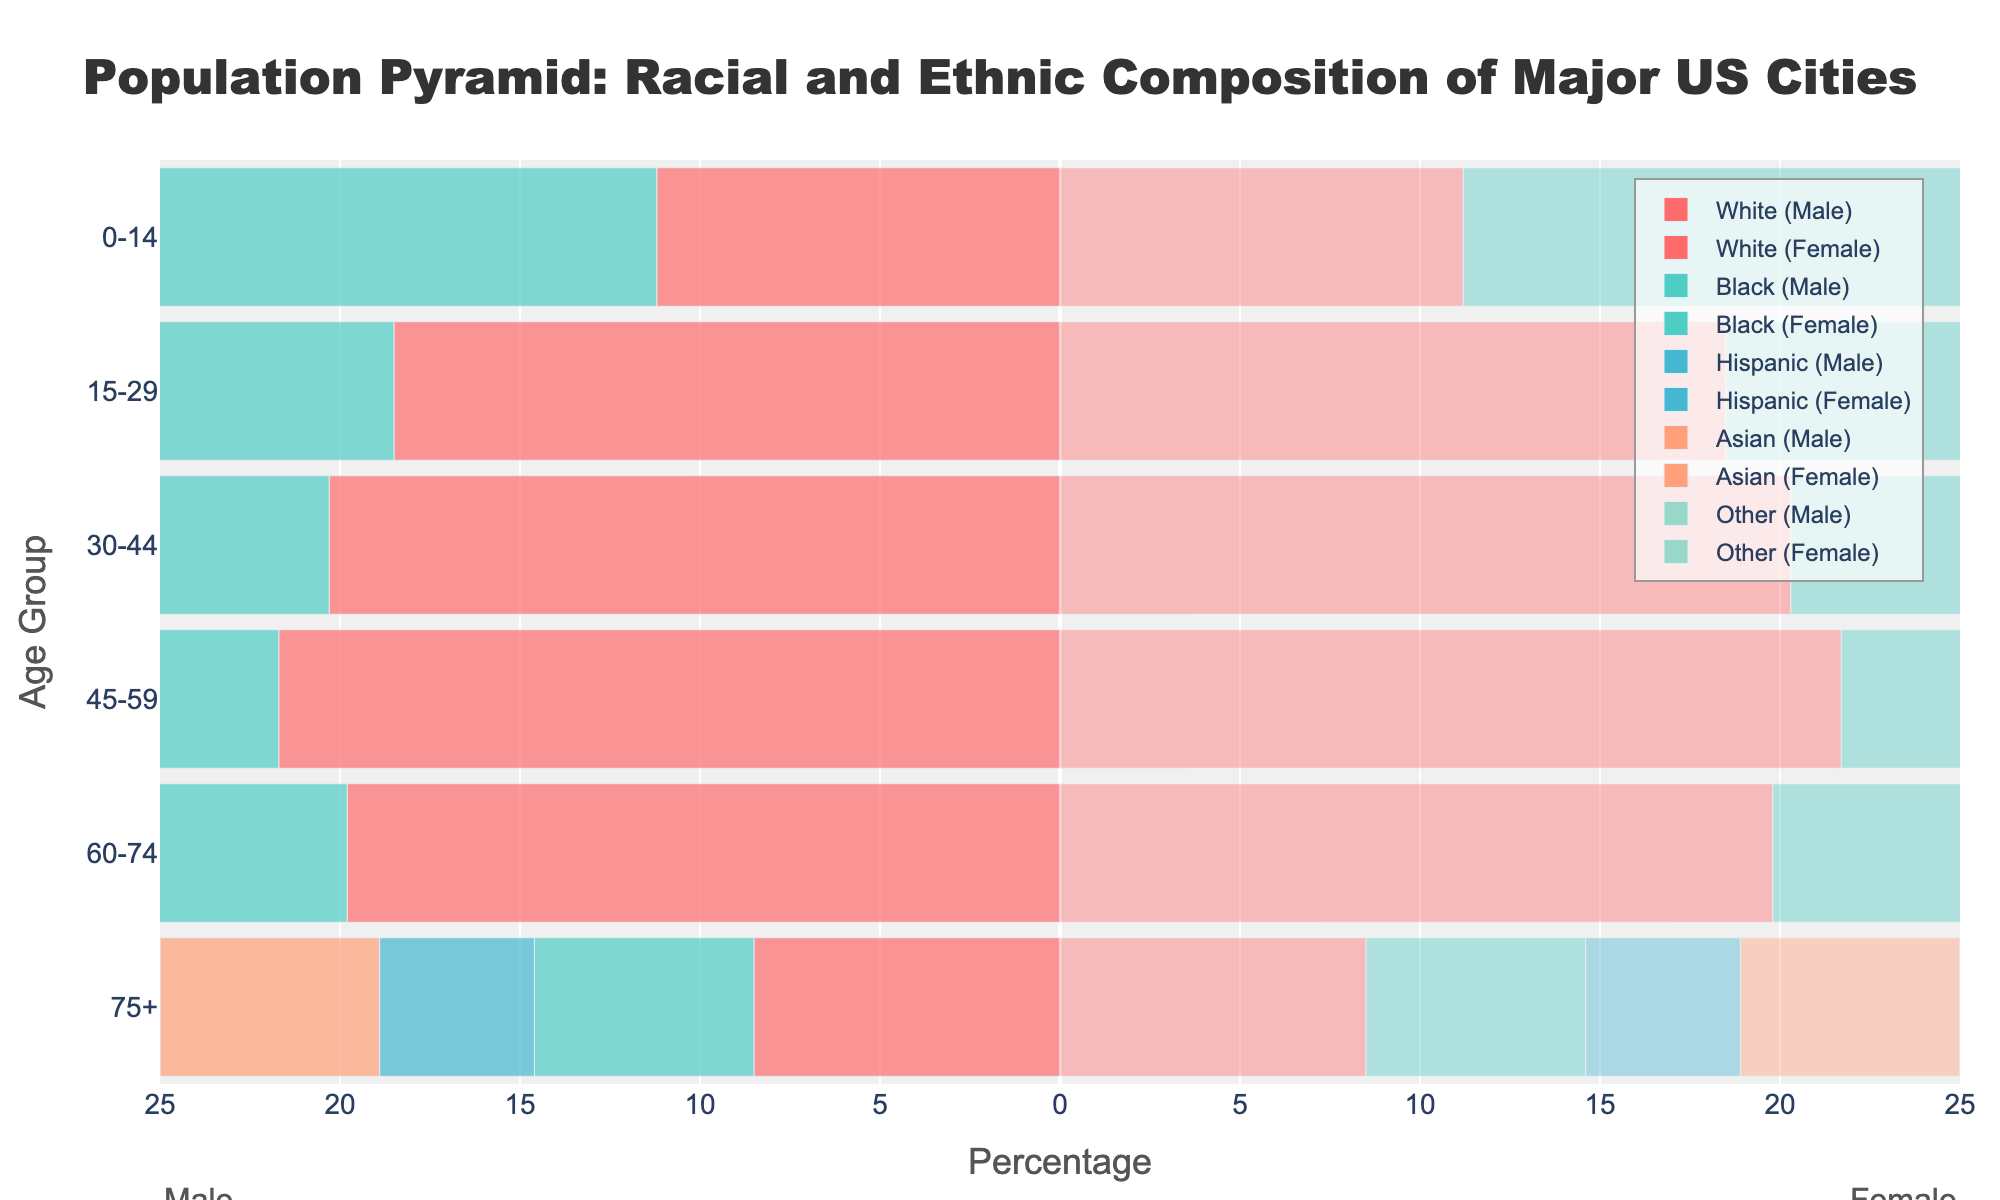What is the title of the figure? The title is usually located at the top of the figure in a larger and bold font. In this figure, it's visible as "Population Pyramid: Racial and Ethnic Composition of Major US Cities".
Answer: Population Pyramid: Racial and Ethnic Composition of Major US Cities Which age group has the highest percentage of Hispanic population? To find the age group with the highest percentage of Hispanic population, look at the bars for the Hispanic category and identify which age group has the longest bar. In this figure, the 30-44 age group has the highest percentage of Hispanic population at 23.1%.
Answer: 30-44 Which racial group has the smallest percentage in the 75+ age group? Compare the lengths of the bars for each racial group within the 75+ age group. The Hispanic group has the smallest percentage at 4.3%.
Answer: Hispanic How does the percentage of Black individuals in the 45-59 age group compare to that in the 60-74 age group? Look at the Black bars for both age groups. For the 45-59 age group, the percentage is 22.4%. For the 60-74 age group, it is 15.9%. This shows the percentage is higher in the 45-59 age group.
Answer: Higher in the 45-59 age group What is the combined percentage of White individuals in the 30-44 and 45-59 age groups? Add the percentages of White individuals in the 30-44 and 45-59 age groups. For the 30-44 age group, it is 20.3%, and for the 45-59 age group, it is 21.7%. The combined percentage is 20.3% + 21.7% = 42.0%.
Answer: 42.0% Which age group has the most similar percentages for the White and Asian populations? Compare the bars of the White and Asian populations across all age groups to find the most similar lengths. In the 60-74 age group, White is 19.8% and Asian is 16.2%, which is the closest match.
Answer: 60-74 Are there more males or females in the 0-14 age group for the Black population? By looking at the figure, we can determine the category by its negative or positive value. Compare the lengths of the negative (male) and positive (female) bars for the Black population in the 0-14 age group. Both are equal at 15.8%.
Answer: Equal What's the total percentage of the population aged 15-29 for all racial groups combined? To find the total for the 15-29 age group, sum the percentages of each racial group: White (18.5%) + Black (20.1%) + Hispanic (22.7%) + Asian (19.8%) + Other (21.3%). The total is 18.5% + 20.1% + 22.7% + 19.8% + 21.3% = 102.4%.
Answer: 102.4% Which race has a higher percentage in the 0-14 age group compared to the 75+ age group? Compare the percentages of each racial group between the 0-14 and 75+ age groups. Every group has a higher percentage in the 0-14 age group than in the 75+ age group, but the difference is stark for Hispanic, Black, and Other categories.
Answer: All groups (but more stark for Hispanic, Black, and Other) Do Asians have a higher or lower percentage in the 30-44 age group compared to the 60-74 age group? Compare the percentages of the Asian population between the 30-44 and 60-74 age groups. The 30-44 age group has 22.5% and the 60-74 age group has 16.2%, indicating a higher percentage in the 30-44 age group.
Answer: Higher in the 30-44 age group 